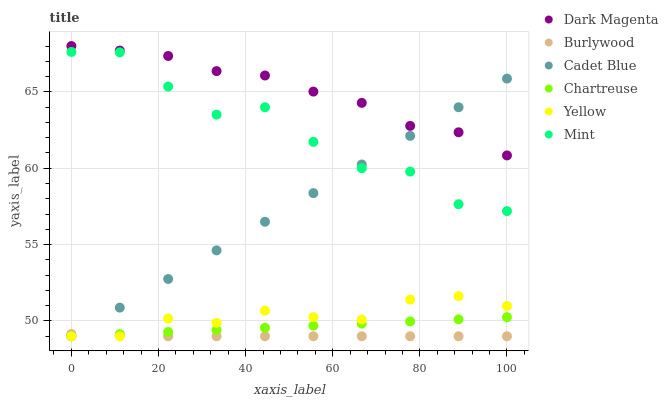Does Burlywood have the minimum area under the curve?
Answer yes or no. Yes. Does Dark Magenta have the maximum area under the curve?
Answer yes or no. Yes. Does Dark Magenta have the minimum area under the curve?
Answer yes or no. No. Does Burlywood have the maximum area under the curve?
Answer yes or no. No. Is Cadet Blue the smoothest?
Answer yes or no. Yes. Is Mint the roughest?
Answer yes or no. Yes. Is Dark Magenta the smoothest?
Answer yes or no. No. Is Dark Magenta the roughest?
Answer yes or no. No. Does Cadet Blue have the lowest value?
Answer yes or no. Yes. Does Dark Magenta have the lowest value?
Answer yes or no. No. Does Dark Magenta have the highest value?
Answer yes or no. Yes. Does Burlywood have the highest value?
Answer yes or no. No. Is Burlywood less than Mint?
Answer yes or no. Yes. Is Mint greater than Yellow?
Answer yes or no. Yes. Does Cadet Blue intersect Yellow?
Answer yes or no. Yes. Is Cadet Blue less than Yellow?
Answer yes or no. No. Is Cadet Blue greater than Yellow?
Answer yes or no. No. Does Burlywood intersect Mint?
Answer yes or no. No. 